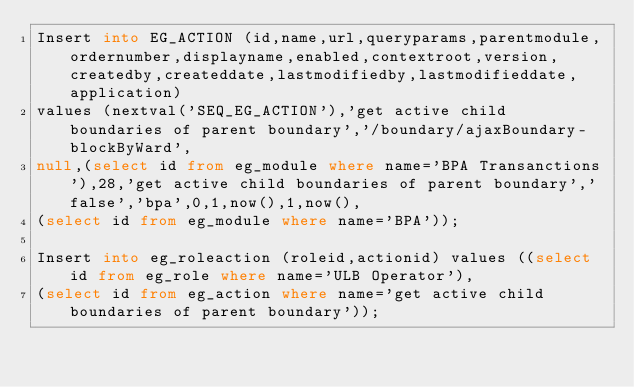<code> <loc_0><loc_0><loc_500><loc_500><_SQL_>Insert into EG_ACTION (id,name,url,queryparams,parentmodule,ordernumber,displayname,enabled,contextroot,version,createdby,createddate,lastmodifiedby,lastmodifieddate,application) 
values (nextval('SEQ_EG_ACTION'),'get active child boundaries of parent boundary','/boundary/ajaxBoundary-blockByWard',
null,(select id from eg_module where name='BPA Transanctions'),28,'get active child boundaries of parent boundary','false','bpa',0,1,now(),1,now(),
(select id from eg_module where name='BPA'));

Insert into eg_roleaction (roleid,actionid) values ((select id from eg_role where name='ULB Operator'),
(select id from eg_action where name='get active child boundaries of parent boundary'));
</code> 